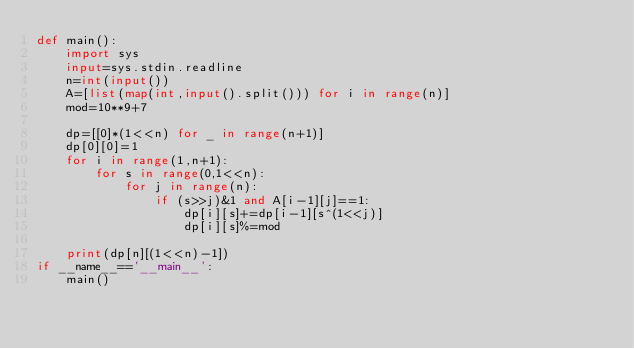<code> <loc_0><loc_0><loc_500><loc_500><_Python_>def main():
    import sys
    input=sys.stdin.readline
    n=int(input())
    A=[list(map(int,input().split())) for i in range(n)]
    mod=10**9+7

    dp=[[0]*(1<<n) for _ in range(n+1)]
    dp[0][0]=1
    for i in range(1,n+1):
        for s in range(0,1<<n):
            for j in range(n):
                if (s>>j)&1 and A[i-1][j]==1:
                    dp[i][s]+=dp[i-1][s^(1<<j)]
                    dp[i][s]%=mod
                    
    print(dp[n][(1<<n)-1])
if __name__=='__main__':
    main()</code> 